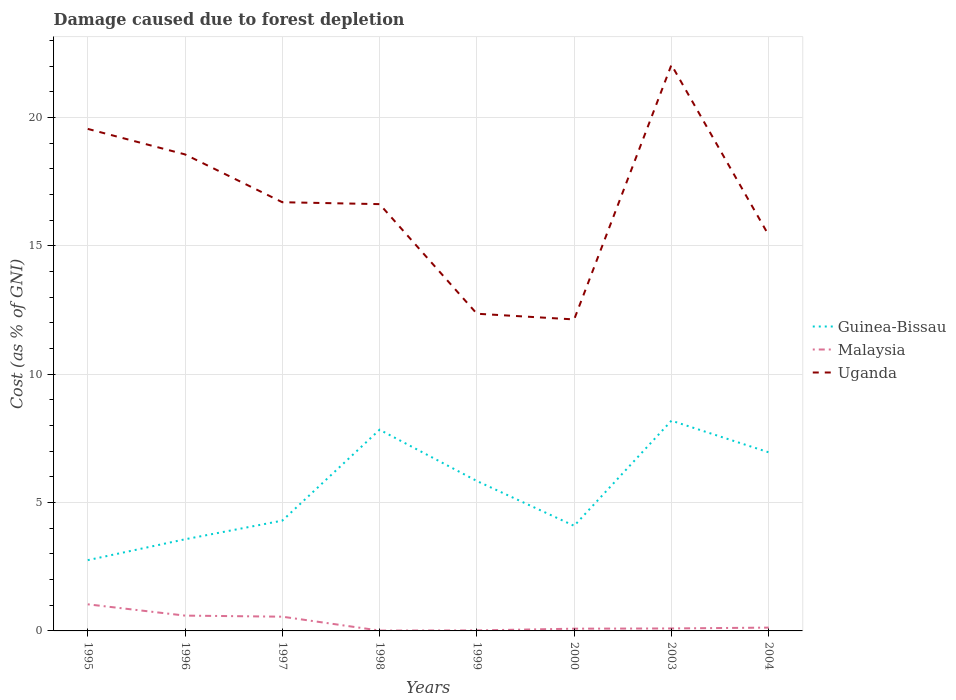Does the line corresponding to Malaysia intersect with the line corresponding to Uganda?
Offer a very short reply. No. Across all years, what is the maximum cost of damage caused due to forest depletion in Guinea-Bissau?
Provide a succinct answer. 2.76. In which year was the cost of damage caused due to forest depletion in Malaysia maximum?
Give a very brief answer. 1998. What is the total cost of damage caused due to forest depletion in Uganda in the graph?
Offer a terse response. 6.21. What is the difference between the highest and the second highest cost of damage caused due to forest depletion in Uganda?
Make the answer very short. 9.91. What is the difference between the highest and the lowest cost of damage caused due to forest depletion in Guinea-Bissau?
Your answer should be compact. 4. How many lines are there?
Your answer should be very brief. 3. Are the values on the major ticks of Y-axis written in scientific E-notation?
Your answer should be compact. No. Does the graph contain any zero values?
Ensure brevity in your answer.  No. What is the title of the graph?
Make the answer very short. Damage caused due to forest depletion. What is the label or title of the X-axis?
Offer a very short reply. Years. What is the label or title of the Y-axis?
Ensure brevity in your answer.  Cost (as % of GNI). What is the Cost (as % of GNI) in Guinea-Bissau in 1995?
Provide a succinct answer. 2.76. What is the Cost (as % of GNI) of Malaysia in 1995?
Provide a short and direct response. 1.04. What is the Cost (as % of GNI) of Uganda in 1995?
Give a very brief answer. 19.55. What is the Cost (as % of GNI) of Guinea-Bissau in 1996?
Offer a very short reply. 3.57. What is the Cost (as % of GNI) of Malaysia in 1996?
Your answer should be compact. 0.6. What is the Cost (as % of GNI) in Uganda in 1996?
Your answer should be very brief. 18.56. What is the Cost (as % of GNI) in Guinea-Bissau in 1997?
Provide a succinct answer. 4.3. What is the Cost (as % of GNI) of Malaysia in 1997?
Your response must be concise. 0.55. What is the Cost (as % of GNI) of Uganda in 1997?
Keep it short and to the point. 16.7. What is the Cost (as % of GNI) of Guinea-Bissau in 1998?
Keep it short and to the point. 7.84. What is the Cost (as % of GNI) in Malaysia in 1998?
Your response must be concise. 0.01. What is the Cost (as % of GNI) in Uganda in 1998?
Your response must be concise. 16.62. What is the Cost (as % of GNI) of Guinea-Bissau in 1999?
Provide a succinct answer. 5.84. What is the Cost (as % of GNI) in Malaysia in 1999?
Provide a succinct answer. 0.02. What is the Cost (as % of GNI) of Uganda in 1999?
Your answer should be compact. 12.35. What is the Cost (as % of GNI) of Guinea-Bissau in 2000?
Give a very brief answer. 4.09. What is the Cost (as % of GNI) of Malaysia in 2000?
Ensure brevity in your answer.  0.09. What is the Cost (as % of GNI) in Uganda in 2000?
Keep it short and to the point. 12.13. What is the Cost (as % of GNI) of Guinea-Bissau in 2003?
Provide a succinct answer. 8.19. What is the Cost (as % of GNI) of Malaysia in 2003?
Your answer should be very brief. 0.1. What is the Cost (as % of GNI) of Uganda in 2003?
Your answer should be compact. 22.05. What is the Cost (as % of GNI) of Guinea-Bissau in 2004?
Give a very brief answer. 6.96. What is the Cost (as % of GNI) of Malaysia in 2004?
Your answer should be very brief. 0.13. What is the Cost (as % of GNI) of Uganda in 2004?
Provide a succinct answer. 15.41. Across all years, what is the maximum Cost (as % of GNI) in Guinea-Bissau?
Offer a terse response. 8.19. Across all years, what is the maximum Cost (as % of GNI) of Malaysia?
Offer a terse response. 1.04. Across all years, what is the maximum Cost (as % of GNI) of Uganda?
Make the answer very short. 22.05. Across all years, what is the minimum Cost (as % of GNI) in Guinea-Bissau?
Make the answer very short. 2.76. Across all years, what is the minimum Cost (as % of GNI) in Malaysia?
Give a very brief answer. 0.01. Across all years, what is the minimum Cost (as % of GNI) in Uganda?
Offer a terse response. 12.13. What is the total Cost (as % of GNI) in Guinea-Bissau in the graph?
Keep it short and to the point. 43.53. What is the total Cost (as % of GNI) of Malaysia in the graph?
Offer a very short reply. 2.53. What is the total Cost (as % of GNI) in Uganda in the graph?
Provide a short and direct response. 133.36. What is the difference between the Cost (as % of GNI) of Guinea-Bissau in 1995 and that in 1996?
Offer a very short reply. -0.81. What is the difference between the Cost (as % of GNI) of Malaysia in 1995 and that in 1996?
Ensure brevity in your answer.  0.44. What is the difference between the Cost (as % of GNI) of Guinea-Bissau in 1995 and that in 1997?
Your response must be concise. -1.54. What is the difference between the Cost (as % of GNI) of Malaysia in 1995 and that in 1997?
Give a very brief answer. 0.48. What is the difference between the Cost (as % of GNI) in Uganda in 1995 and that in 1997?
Your response must be concise. 2.86. What is the difference between the Cost (as % of GNI) in Guinea-Bissau in 1995 and that in 1998?
Provide a short and direct response. -5.08. What is the difference between the Cost (as % of GNI) in Malaysia in 1995 and that in 1998?
Provide a succinct answer. 1.02. What is the difference between the Cost (as % of GNI) of Uganda in 1995 and that in 1998?
Give a very brief answer. 2.93. What is the difference between the Cost (as % of GNI) of Guinea-Bissau in 1995 and that in 1999?
Keep it short and to the point. -3.08. What is the difference between the Cost (as % of GNI) in Malaysia in 1995 and that in 1999?
Provide a short and direct response. 1.02. What is the difference between the Cost (as % of GNI) in Uganda in 1995 and that in 1999?
Make the answer very short. 7.2. What is the difference between the Cost (as % of GNI) of Guinea-Bissau in 1995 and that in 2000?
Make the answer very short. -1.34. What is the difference between the Cost (as % of GNI) of Malaysia in 1995 and that in 2000?
Provide a succinct answer. 0.95. What is the difference between the Cost (as % of GNI) of Uganda in 1995 and that in 2000?
Ensure brevity in your answer.  7.42. What is the difference between the Cost (as % of GNI) in Guinea-Bissau in 1995 and that in 2003?
Your answer should be compact. -5.43. What is the difference between the Cost (as % of GNI) in Malaysia in 1995 and that in 2003?
Offer a very short reply. 0.94. What is the difference between the Cost (as % of GNI) of Uganda in 1995 and that in 2003?
Offer a terse response. -2.49. What is the difference between the Cost (as % of GNI) of Guinea-Bissau in 1995 and that in 2004?
Offer a terse response. -4.2. What is the difference between the Cost (as % of GNI) in Malaysia in 1995 and that in 2004?
Provide a succinct answer. 0.91. What is the difference between the Cost (as % of GNI) of Uganda in 1995 and that in 2004?
Provide a succinct answer. 4.14. What is the difference between the Cost (as % of GNI) in Guinea-Bissau in 1996 and that in 1997?
Your response must be concise. -0.73. What is the difference between the Cost (as % of GNI) of Malaysia in 1996 and that in 1997?
Provide a succinct answer. 0.04. What is the difference between the Cost (as % of GNI) in Uganda in 1996 and that in 1997?
Provide a succinct answer. 1.86. What is the difference between the Cost (as % of GNI) in Guinea-Bissau in 1996 and that in 1998?
Ensure brevity in your answer.  -4.27. What is the difference between the Cost (as % of GNI) in Malaysia in 1996 and that in 1998?
Make the answer very short. 0.58. What is the difference between the Cost (as % of GNI) of Uganda in 1996 and that in 1998?
Give a very brief answer. 1.94. What is the difference between the Cost (as % of GNI) of Guinea-Bissau in 1996 and that in 1999?
Keep it short and to the point. -2.27. What is the difference between the Cost (as % of GNI) of Malaysia in 1996 and that in 1999?
Give a very brief answer. 0.58. What is the difference between the Cost (as % of GNI) in Uganda in 1996 and that in 1999?
Keep it short and to the point. 6.21. What is the difference between the Cost (as % of GNI) of Guinea-Bissau in 1996 and that in 2000?
Your response must be concise. -0.52. What is the difference between the Cost (as % of GNI) of Malaysia in 1996 and that in 2000?
Your answer should be very brief. 0.51. What is the difference between the Cost (as % of GNI) of Uganda in 1996 and that in 2000?
Make the answer very short. 6.43. What is the difference between the Cost (as % of GNI) of Guinea-Bissau in 1996 and that in 2003?
Provide a succinct answer. -4.62. What is the difference between the Cost (as % of GNI) of Malaysia in 1996 and that in 2003?
Your response must be concise. 0.5. What is the difference between the Cost (as % of GNI) of Uganda in 1996 and that in 2003?
Provide a succinct answer. -3.49. What is the difference between the Cost (as % of GNI) of Guinea-Bissau in 1996 and that in 2004?
Keep it short and to the point. -3.39. What is the difference between the Cost (as % of GNI) in Malaysia in 1996 and that in 2004?
Provide a succinct answer. 0.47. What is the difference between the Cost (as % of GNI) in Uganda in 1996 and that in 2004?
Give a very brief answer. 3.15. What is the difference between the Cost (as % of GNI) of Guinea-Bissau in 1997 and that in 1998?
Provide a succinct answer. -3.54. What is the difference between the Cost (as % of GNI) in Malaysia in 1997 and that in 1998?
Ensure brevity in your answer.  0.54. What is the difference between the Cost (as % of GNI) of Uganda in 1997 and that in 1998?
Your response must be concise. 0.07. What is the difference between the Cost (as % of GNI) in Guinea-Bissau in 1997 and that in 1999?
Keep it short and to the point. -1.54. What is the difference between the Cost (as % of GNI) in Malaysia in 1997 and that in 1999?
Offer a very short reply. 0.53. What is the difference between the Cost (as % of GNI) in Uganda in 1997 and that in 1999?
Your answer should be compact. 4.34. What is the difference between the Cost (as % of GNI) of Guinea-Bissau in 1997 and that in 2000?
Offer a terse response. 0.2. What is the difference between the Cost (as % of GNI) in Malaysia in 1997 and that in 2000?
Your answer should be very brief. 0.47. What is the difference between the Cost (as % of GNI) of Uganda in 1997 and that in 2000?
Offer a terse response. 4.56. What is the difference between the Cost (as % of GNI) of Guinea-Bissau in 1997 and that in 2003?
Ensure brevity in your answer.  -3.89. What is the difference between the Cost (as % of GNI) of Malaysia in 1997 and that in 2003?
Your response must be concise. 0.46. What is the difference between the Cost (as % of GNI) of Uganda in 1997 and that in 2003?
Offer a terse response. -5.35. What is the difference between the Cost (as % of GNI) of Guinea-Bissau in 1997 and that in 2004?
Offer a very short reply. -2.66. What is the difference between the Cost (as % of GNI) of Malaysia in 1997 and that in 2004?
Make the answer very short. 0.43. What is the difference between the Cost (as % of GNI) in Uganda in 1997 and that in 2004?
Offer a terse response. 1.29. What is the difference between the Cost (as % of GNI) in Guinea-Bissau in 1998 and that in 1999?
Your response must be concise. 2. What is the difference between the Cost (as % of GNI) in Malaysia in 1998 and that in 1999?
Your answer should be compact. -0.01. What is the difference between the Cost (as % of GNI) in Uganda in 1998 and that in 1999?
Provide a succinct answer. 4.27. What is the difference between the Cost (as % of GNI) of Guinea-Bissau in 1998 and that in 2000?
Offer a terse response. 3.74. What is the difference between the Cost (as % of GNI) in Malaysia in 1998 and that in 2000?
Provide a succinct answer. -0.07. What is the difference between the Cost (as % of GNI) in Uganda in 1998 and that in 2000?
Keep it short and to the point. 4.49. What is the difference between the Cost (as % of GNI) of Guinea-Bissau in 1998 and that in 2003?
Make the answer very short. -0.35. What is the difference between the Cost (as % of GNI) in Malaysia in 1998 and that in 2003?
Provide a short and direct response. -0.08. What is the difference between the Cost (as % of GNI) in Uganda in 1998 and that in 2003?
Give a very brief answer. -5.42. What is the difference between the Cost (as % of GNI) of Guinea-Bissau in 1998 and that in 2004?
Your answer should be compact. 0.88. What is the difference between the Cost (as % of GNI) of Malaysia in 1998 and that in 2004?
Provide a short and direct response. -0.11. What is the difference between the Cost (as % of GNI) of Uganda in 1998 and that in 2004?
Your answer should be very brief. 1.21. What is the difference between the Cost (as % of GNI) in Guinea-Bissau in 1999 and that in 2000?
Your response must be concise. 1.75. What is the difference between the Cost (as % of GNI) in Malaysia in 1999 and that in 2000?
Make the answer very short. -0.07. What is the difference between the Cost (as % of GNI) in Uganda in 1999 and that in 2000?
Your answer should be very brief. 0.22. What is the difference between the Cost (as % of GNI) in Guinea-Bissau in 1999 and that in 2003?
Your answer should be very brief. -2.35. What is the difference between the Cost (as % of GNI) in Malaysia in 1999 and that in 2003?
Make the answer very short. -0.08. What is the difference between the Cost (as % of GNI) in Uganda in 1999 and that in 2003?
Your answer should be compact. -9.69. What is the difference between the Cost (as % of GNI) of Guinea-Bissau in 1999 and that in 2004?
Your answer should be very brief. -1.12. What is the difference between the Cost (as % of GNI) in Malaysia in 1999 and that in 2004?
Provide a succinct answer. -0.11. What is the difference between the Cost (as % of GNI) of Uganda in 1999 and that in 2004?
Provide a succinct answer. -3.06. What is the difference between the Cost (as % of GNI) of Guinea-Bissau in 2000 and that in 2003?
Make the answer very short. -4.1. What is the difference between the Cost (as % of GNI) of Malaysia in 2000 and that in 2003?
Your answer should be compact. -0.01. What is the difference between the Cost (as % of GNI) of Uganda in 2000 and that in 2003?
Your response must be concise. -9.91. What is the difference between the Cost (as % of GNI) of Guinea-Bissau in 2000 and that in 2004?
Provide a succinct answer. -2.86. What is the difference between the Cost (as % of GNI) in Malaysia in 2000 and that in 2004?
Your answer should be compact. -0.04. What is the difference between the Cost (as % of GNI) of Uganda in 2000 and that in 2004?
Give a very brief answer. -3.28. What is the difference between the Cost (as % of GNI) in Guinea-Bissau in 2003 and that in 2004?
Make the answer very short. 1.23. What is the difference between the Cost (as % of GNI) of Malaysia in 2003 and that in 2004?
Provide a short and direct response. -0.03. What is the difference between the Cost (as % of GNI) of Uganda in 2003 and that in 2004?
Your answer should be compact. 6.64. What is the difference between the Cost (as % of GNI) of Guinea-Bissau in 1995 and the Cost (as % of GNI) of Malaysia in 1996?
Your answer should be very brief. 2.16. What is the difference between the Cost (as % of GNI) of Guinea-Bissau in 1995 and the Cost (as % of GNI) of Uganda in 1996?
Offer a very short reply. -15.8. What is the difference between the Cost (as % of GNI) in Malaysia in 1995 and the Cost (as % of GNI) in Uganda in 1996?
Provide a short and direct response. -17.52. What is the difference between the Cost (as % of GNI) in Guinea-Bissau in 1995 and the Cost (as % of GNI) in Malaysia in 1997?
Keep it short and to the point. 2.2. What is the difference between the Cost (as % of GNI) of Guinea-Bissau in 1995 and the Cost (as % of GNI) of Uganda in 1997?
Ensure brevity in your answer.  -13.94. What is the difference between the Cost (as % of GNI) of Malaysia in 1995 and the Cost (as % of GNI) of Uganda in 1997?
Provide a succinct answer. -15.66. What is the difference between the Cost (as % of GNI) of Guinea-Bissau in 1995 and the Cost (as % of GNI) of Malaysia in 1998?
Keep it short and to the point. 2.74. What is the difference between the Cost (as % of GNI) in Guinea-Bissau in 1995 and the Cost (as % of GNI) in Uganda in 1998?
Provide a succinct answer. -13.87. What is the difference between the Cost (as % of GNI) in Malaysia in 1995 and the Cost (as % of GNI) in Uganda in 1998?
Make the answer very short. -15.59. What is the difference between the Cost (as % of GNI) in Guinea-Bissau in 1995 and the Cost (as % of GNI) in Malaysia in 1999?
Provide a succinct answer. 2.74. What is the difference between the Cost (as % of GNI) in Guinea-Bissau in 1995 and the Cost (as % of GNI) in Uganda in 1999?
Your response must be concise. -9.6. What is the difference between the Cost (as % of GNI) of Malaysia in 1995 and the Cost (as % of GNI) of Uganda in 1999?
Offer a terse response. -11.32. What is the difference between the Cost (as % of GNI) in Guinea-Bissau in 1995 and the Cost (as % of GNI) in Malaysia in 2000?
Provide a short and direct response. 2.67. What is the difference between the Cost (as % of GNI) in Guinea-Bissau in 1995 and the Cost (as % of GNI) in Uganda in 2000?
Offer a terse response. -9.38. What is the difference between the Cost (as % of GNI) in Malaysia in 1995 and the Cost (as % of GNI) in Uganda in 2000?
Your answer should be compact. -11.1. What is the difference between the Cost (as % of GNI) in Guinea-Bissau in 1995 and the Cost (as % of GNI) in Malaysia in 2003?
Give a very brief answer. 2.66. What is the difference between the Cost (as % of GNI) of Guinea-Bissau in 1995 and the Cost (as % of GNI) of Uganda in 2003?
Your answer should be very brief. -19.29. What is the difference between the Cost (as % of GNI) of Malaysia in 1995 and the Cost (as % of GNI) of Uganda in 2003?
Offer a very short reply. -21.01. What is the difference between the Cost (as % of GNI) of Guinea-Bissau in 1995 and the Cost (as % of GNI) of Malaysia in 2004?
Your answer should be very brief. 2.63. What is the difference between the Cost (as % of GNI) in Guinea-Bissau in 1995 and the Cost (as % of GNI) in Uganda in 2004?
Give a very brief answer. -12.65. What is the difference between the Cost (as % of GNI) of Malaysia in 1995 and the Cost (as % of GNI) of Uganda in 2004?
Your answer should be compact. -14.37. What is the difference between the Cost (as % of GNI) in Guinea-Bissau in 1996 and the Cost (as % of GNI) in Malaysia in 1997?
Ensure brevity in your answer.  3.01. What is the difference between the Cost (as % of GNI) in Guinea-Bissau in 1996 and the Cost (as % of GNI) in Uganda in 1997?
Give a very brief answer. -13.13. What is the difference between the Cost (as % of GNI) of Malaysia in 1996 and the Cost (as % of GNI) of Uganda in 1997?
Your answer should be very brief. -16.1. What is the difference between the Cost (as % of GNI) of Guinea-Bissau in 1996 and the Cost (as % of GNI) of Malaysia in 1998?
Make the answer very short. 3.55. What is the difference between the Cost (as % of GNI) in Guinea-Bissau in 1996 and the Cost (as % of GNI) in Uganda in 1998?
Keep it short and to the point. -13.05. What is the difference between the Cost (as % of GNI) of Malaysia in 1996 and the Cost (as % of GNI) of Uganda in 1998?
Offer a terse response. -16.02. What is the difference between the Cost (as % of GNI) of Guinea-Bissau in 1996 and the Cost (as % of GNI) of Malaysia in 1999?
Your answer should be compact. 3.55. What is the difference between the Cost (as % of GNI) in Guinea-Bissau in 1996 and the Cost (as % of GNI) in Uganda in 1999?
Offer a very short reply. -8.78. What is the difference between the Cost (as % of GNI) of Malaysia in 1996 and the Cost (as % of GNI) of Uganda in 1999?
Provide a succinct answer. -11.76. What is the difference between the Cost (as % of GNI) of Guinea-Bissau in 1996 and the Cost (as % of GNI) of Malaysia in 2000?
Offer a terse response. 3.48. What is the difference between the Cost (as % of GNI) of Guinea-Bissau in 1996 and the Cost (as % of GNI) of Uganda in 2000?
Offer a terse response. -8.56. What is the difference between the Cost (as % of GNI) in Malaysia in 1996 and the Cost (as % of GNI) in Uganda in 2000?
Offer a very short reply. -11.53. What is the difference between the Cost (as % of GNI) in Guinea-Bissau in 1996 and the Cost (as % of GNI) in Malaysia in 2003?
Offer a terse response. 3.47. What is the difference between the Cost (as % of GNI) in Guinea-Bissau in 1996 and the Cost (as % of GNI) in Uganda in 2003?
Your answer should be very brief. -18.48. What is the difference between the Cost (as % of GNI) of Malaysia in 1996 and the Cost (as % of GNI) of Uganda in 2003?
Give a very brief answer. -21.45. What is the difference between the Cost (as % of GNI) of Guinea-Bissau in 1996 and the Cost (as % of GNI) of Malaysia in 2004?
Keep it short and to the point. 3.44. What is the difference between the Cost (as % of GNI) in Guinea-Bissau in 1996 and the Cost (as % of GNI) in Uganda in 2004?
Offer a terse response. -11.84. What is the difference between the Cost (as % of GNI) in Malaysia in 1996 and the Cost (as % of GNI) in Uganda in 2004?
Provide a short and direct response. -14.81. What is the difference between the Cost (as % of GNI) in Guinea-Bissau in 1997 and the Cost (as % of GNI) in Malaysia in 1998?
Keep it short and to the point. 4.28. What is the difference between the Cost (as % of GNI) in Guinea-Bissau in 1997 and the Cost (as % of GNI) in Uganda in 1998?
Keep it short and to the point. -12.33. What is the difference between the Cost (as % of GNI) of Malaysia in 1997 and the Cost (as % of GNI) of Uganda in 1998?
Your answer should be compact. -16.07. What is the difference between the Cost (as % of GNI) in Guinea-Bissau in 1997 and the Cost (as % of GNI) in Malaysia in 1999?
Give a very brief answer. 4.28. What is the difference between the Cost (as % of GNI) of Guinea-Bissau in 1997 and the Cost (as % of GNI) of Uganda in 1999?
Keep it short and to the point. -8.06. What is the difference between the Cost (as % of GNI) in Malaysia in 1997 and the Cost (as % of GNI) in Uganda in 1999?
Ensure brevity in your answer.  -11.8. What is the difference between the Cost (as % of GNI) in Guinea-Bissau in 1997 and the Cost (as % of GNI) in Malaysia in 2000?
Your response must be concise. 4.21. What is the difference between the Cost (as % of GNI) in Guinea-Bissau in 1997 and the Cost (as % of GNI) in Uganda in 2000?
Provide a short and direct response. -7.84. What is the difference between the Cost (as % of GNI) in Malaysia in 1997 and the Cost (as % of GNI) in Uganda in 2000?
Offer a very short reply. -11.58. What is the difference between the Cost (as % of GNI) of Guinea-Bissau in 1997 and the Cost (as % of GNI) of Malaysia in 2003?
Offer a terse response. 4.2. What is the difference between the Cost (as % of GNI) in Guinea-Bissau in 1997 and the Cost (as % of GNI) in Uganda in 2003?
Make the answer very short. -17.75. What is the difference between the Cost (as % of GNI) of Malaysia in 1997 and the Cost (as % of GNI) of Uganda in 2003?
Make the answer very short. -21.49. What is the difference between the Cost (as % of GNI) in Guinea-Bissau in 1997 and the Cost (as % of GNI) in Malaysia in 2004?
Offer a very short reply. 4.17. What is the difference between the Cost (as % of GNI) in Guinea-Bissau in 1997 and the Cost (as % of GNI) in Uganda in 2004?
Keep it short and to the point. -11.11. What is the difference between the Cost (as % of GNI) of Malaysia in 1997 and the Cost (as % of GNI) of Uganda in 2004?
Keep it short and to the point. -14.85. What is the difference between the Cost (as % of GNI) of Guinea-Bissau in 1998 and the Cost (as % of GNI) of Malaysia in 1999?
Provide a succinct answer. 7.82. What is the difference between the Cost (as % of GNI) in Guinea-Bissau in 1998 and the Cost (as % of GNI) in Uganda in 1999?
Make the answer very short. -4.52. What is the difference between the Cost (as % of GNI) of Malaysia in 1998 and the Cost (as % of GNI) of Uganda in 1999?
Your answer should be compact. -12.34. What is the difference between the Cost (as % of GNI) of Guinea-Bissau in 1998 and the Cost (as % of GNI) of Malaysia in 2000?
Your answer should be compact. 7.75. What is the difference between the Cost (as % of GNI) of Guinea-Bissau in 1998 and the Cost (as % of GNI) of Uganda in 2000?
Offer a terse response. -4.3. What is the difference between the Cost (as % of GNI) in Malaysia in 1998 and the Cost (as % of GNI) in Uganda in 2000?
Provide a short and direct response. -12.12. What is the difference between the Cost (as % of GNI) in Guinea-Bissau in 1998 and the Cost (as % of GNI) in Malaysia in 2003?
Make the answer very short. 7.74. What is the difference between the Cost (as % of GNI) of Guinea-Bissau in 1998 and the Cost (as % of GNI) of Uganda in 2003?
Your response must be concise. -14.21. What is the difference between the Cost (as % of GNI) in Malaysia in 1998 and the Cost (as % of GNI) in Uganda in 2003?
Provide a short and direct response. -22.03. What is the difference between the Cost (as % of GNI) of Guinea-Bissau in 1998 and the Cost (as % of GNI) of Malaysia in 2004?
Offer a very short reply. 7.71. What is the difference between the Cost (as % of GNI) of Guinea-Bissau in 1998 and the Cost (as % of GNI) of Uganda in 2004?
Your answer should be very brief. -7.57. What is the difference between the Cost (as % of GNI) of Malaysia in 1998 and the Cost (as % of GNI) of Uganda in 2004?
Keep it short and to the point. -15.39. What is the difference between the Cost (as % of GNI) in Guinea-Bissau in 1999 and the Cost (as % of GNI) in Malaysia in 2000?
Offer a terse response. 5.75. What is the difference between the Cost (as % of GNI) of Guinea-Bissau in 1999 and the Cost (as % of GNI) of Uganda in 2000?
Ensure brevity in your answer.  -6.29. What is the difference between the Cost (as % of GNI) of Malaysia in 1999 and the Cost (as % of GNI) of Uganda in 2000?
Give a very brief answer. -12.11. What is the difference between the Cost (as % of GNI) in Guinea-Bissau in 1999 and the Cost (as % of GNI) in Malaysia in 2003?
Provide a short and direct response. 5.74. What is the difference between the Cost (as % of GNI) in Guinea-Bissau in 1999 and the Cost (as % of GNI) in Uganda in 2003?
Ensure brevity in your answer.  -16.21. What is the difference between the Cost (as % of GNI) of Malaysia in 1999 and the Cost (as % of GNI) of Uganda in 2003?
Provide a short and direct response. -22.03. What is the difference between the Cost (as % of GNI) of Guinea-Bissau in 1999 and the Cost (as % of GNI) of Malaysia in 2004?
Offer a terse response. 5.71. What is the difference between the Cost (as % of GNI) in Guinea-Bissau in 1999 and the Cost (as % of GNI) in Uganda in 2004?
Give a very brief answer. -9.57. What is the difference between the Cost (as % of GNI) of Malaysia in 1999 and the Cost (as % of GNI) of Uganda in 2004?
Your answer should be very brief. -15.39. What is the difference between the Cost (as % of GNI) in Guinea-Bissau in 2000 and the Cost (as % of GNI) in Malaysia in 2003?
Provide a short and direct response. 4. What is the difference between the Cost (as % of GNI) of Guinea-Bissau in 2000 and the Cost (as % of GNI) of Uganda in 2003?
Provide a short and direct response. -17.95. What is the difference between the Cost (as % of GNI) of Malaysia in 2000 and the Cost (as % of GNI) of Uganda in 2003?
Offer a terse response. -21.96. What is the difference between the Cost (as % of GNI) in Guinea-Bissau in 2000 and the Cost (as % of GNI) in Malaysia in 2004?
Make the answer very short. 3.96. What is the difference between the Cost (as % of GNI) of Guinea-Bissau in 2000 and the Cost (as % of GNI) of Uganda in 2004?
Offer a terse response. -11.32. What is the difference between the Cost (as % of GNI) of Malaysia in 2000 and the Cost (as % of GNI) of Uganda in 2004?
Offer a terse response. -15.32. What is the difference between the Cost (as % of GNI) of Guinea-Bissau in 2003 and the Cost (as % of GNI) of Malaysia in 2004?
Ensure brevity in your answer.  8.06. What is the difference between the Cost (as % of GNI) of Guinea-Bissau in 2003 and the Cost (as % of GNI) of Uganda in 2004?
Make the answer very short. -7.22. What is the difference between the Cost (as % of GNI) of Malaysia in 2003 and the Cost (as % of GNI) of Uganda in 2004?
Offer a terse response. -15.31. What is the average Cost (as % of GNI) of Guinea-Bissau per year?
Your answer should be compact. 5.44. What is the average Cost (as % of GNI) of Malaysia per year?
Give a very brief answer. 0.32. What is the average Cost (as % of GNI) of Uganda per year?
Keep it short and to the point. 16.67. In the year 1995, what is the difference between the Cost (as % of GNI) in Guinea-Bissau and Cost (as % of GNI) in Malaysia?
Your answer should be compact. 1.72. In the year 1995, what is the difference between the Cost (as % of GNI) of Guinea-Bissau and Cost (as % of GNI) of Uganda?
Provide a succinct answer. -16.8. In the year 1995, what is the difference between the Cost (as % of GNI) in Malaysia and Cost (as % of GNI) in Uganda?
Offer a terse response. -18.52. In the year 1996, what is the difference between the Cost (as % of GNI) in Guinea-Bissau and Cost (as % of GNI) in Malaysia?
Make the answer very short. 2.97. In the year 1996, what is the difference between the Cost (as % of GNI) in Guinea-Bissau and Cost (as % of GNI) in Uganda?
Give a very brief answer. -14.99. In the year 1996, what is the difference between the Cost (as % of GNI) in Malaysia and Cost (as % of GNI) in Uganda?
Keep it short and to the point. -17.96. In the year 1997, what is the difference between the Cost (as % of GNI) in Guinea-Bissau and Cost (as % of GNI) in Malaysia?
Offer a terse response. 3.74. In the year 1997, what is the difference between the Cost (as % of GNI) of Guinea-Bissau and Cost (as % of GNI) of Uganda?
Keep it short and to the point. -12.4. In the year 1997, what is the difference between the Cost (as % of GNI) of Malaysia and Cost (as % of GNI) of Uganda?
Offer a very short reply. -16.14. In the year 1998, what is the difference between the Cost (as % of GNI) of Guinea-Bissau and Cost (as % of GNI) of Malaysia?
Your answer should be compact. 7.82. In the year 1998, what is the difference between the Cost (as % of GNI) of Guinea-Bissau and Cost (as % of GNI) of Uganda?
Give a very brief answer. -8.79. In the year 1998, what is the difference between the Cost (as % of GNI) in Malaysia and Cost (as % of GNI) in Uganda?
Offer a terse response. -16.61. In the year 1999, what is the difference between the Cost (as % of GNI) in Guinea-Bissau and Cost (as % of GNI) in Malaysia?
Your answer should be compact. 5.82. In the year 1999, what is the difference between the Cost (as % of GNI) in Guinea-Bissau and Cost (as % of GNI) in Uganda?
Your response must be concise. -6.51. In the year 1999, what is the difference between the Cost (as % of GNI) in Malaysia and Cost (as % of GNI) in Uganda?
Offer a very short reply. -12.33. In the year 2000, what is the difference between the Cost (as % of GNI) in Guinea-Bissau and Cost (as % of GNI) in Malaysia?
Ensure brevity in your answer.  4.01. In the year 2000, what is the difference between the Cost (as % of GNI) of Guinea-Bissau and Cost (as % of GNI) of Uganda?
Give a very brief answer. -8.04. In the year 2000, what is the difference between the Cost (as % of GNI) in Malaysia and Cost (as % of GNI) in Uganda?
Provide a short and direct response. -12.04. In the year 2003, what is the difference between the Cost (as % of GNI) of Guinea-Bissau and Cost (as % of GNI) of Malaysia?
Keep it short and to the point. 8.09. In the year 2003, what is the difference between the Cost (as % of GNI) in Guinea-Bissau and Cost (as % of GNI) in Uganda?
Provide a succinct answer. -13.86. In the year 2003, what is the difference between the Cost (as % of GNI) of Malaysia and Cost (as % of GNI) of Uganda?
Your answer should be compact. -21.95. In the year 2004, what is the difference between the Cost (as % of GNI) of Guinea-Bissau and Cost (as % of GNI) of Malaysia?
Offer a terse response. 6.83. In the year 2004, what is the difference between the Cost (as % of GNI) of Guinea-Bissau and Cost (as % of GNI) of Uganda?
Your answer should be very brief. -8.45. In the year 2004, what is the difference between the Cost (as % of GNI) in Malaysia and Cost (as % of GNI) in Uganda?
Make the answer very short. -15.28. What is the ratio of the Cost (as % of GNI) in Guinea-Bissau in 1995 to that in 1996?
Offer a terse response. 0.77. What is the ratio of the Cost (as % of GNI) in Malaysia in 1995 to that in 1996?
Ensure brevity in your answer.  1.74. What is the ratio of the Cost (as % of GNI) of Uganda in 1995 to that in 1996?
Ensure brevity in your answer.  1.05. What is the ratio of the Cost (as % of GNI) in Guinea-Bissau in 1995 to that in 1997?
Offer a very short reply. 0.64. What is the ratio of the Cost (as % of GNI) of Malaysia in 1995 to that in 1997?
Give a very brief answer. 1.87. What is the ratio of the Cost (as % of GNI) in Uganda in 1995 to that in 1997?
Ensure brevity in your answer.  1.17. What is the ratio of the Cost (as % of GNI) in Guinea-Bissau in 1995 to that in 1998?
Your answer should be compact. 0.35. What is the ratio of the Cost (as % of GNI) in Malaysia in 1995 to that in 1998?
Offer a very short reply. 73.46. What is the ratio of the Cost (as % of GNI) in Uganda in 1995 to that in 1998?
Keep it short and to the point. 1.18. What is the ratio of the Cost (as % of GNI) in Guinea-Bissau in 1995 to that in 1999?
Provide a short and direct response. 0.47. What is the ratio of the Cost (as % of GNI) in Malaysia in 1995 to that in 1999?
Offer a very short reply. 52.17. What is the ratio of the Cost (as % of GNI) in Uganda in 1995 to that in 1999?
Your answer should be very brief. 1.58. What is the ratio of the Cost (as % of GNI) in Guinea-Bissau in 1995 to that in 2000?
Provide a short and direct response. 0.67. What is the ratio of the Cost (as % of GNI) in Malaysia in 1995 to that in 2000?
Provide a succinct answer. 11.87. What is the ratio of the Cost (as % of GNI) of Uganda in 1995 to that in 2000?
Give a very brief answer. 1.61. What is the ratio of the Cost (as % of GNI) in Guinea-Bissau in 1995 to that in 2003?
Provide a short and direct response. 0.34. What is the ratio of the Cost (as % of GNI) in Malaysia in 1995 to that in 2003?
Keep it short and to the point. 10.79. What is the ratio of the Cost (as % of GNI) of Uganda in 1995 to that in 2003?
Offer a terse response. 0.89. What is the ratio of the Cost (as % of GNI) in Guinea-Bissau in 1995 to that in 2004?
Provide a short and direct response. 0.4. What is the ratio of the Cost (as % of GNI) of Malaysia in 1995 to that in 2004?
Ensure brevity in your answer.  8.04. What is the ratio of the Cost (as % of GNI) of Uganda in 1995 to that in 2004?
Your answer should be compact. 1.27. What is the ratio of the Cost (as % of GNI) in Guinea-Bissau in 1996 to that in 1997?
Keep it short and to the point. 0.83. What is the ratio of the Cost (as % of GNI) in Malaysia in 1996 to that in 1997?
Your answer should be very brief. 1.08. What is the ratio of the Cost (as % of GNI) in Uganda in 1996 to that in 1997?
Provide a short and direct response. 1.11. What is the ratio of the Cost (as % of GNI) in Guinea-Bissau in 1996 to that in 1998?
Ensure brevity in your answer.  0.46. What is the ratio of the Cost (as % of GNI) in Malaysia in 1996 to that in 1998?
Your answer should be compact. 42.29. What is the ratio of the Cost (as % of GNI) in Uganda in 1996 to that in 1998?
Your answer should be compact. 1.12. What is the ratio of the Cost (as % of GNI) of Guinea-Bissau in 1996 to that in 1999?
Provide a succinct answer. 0.61. What is the ratio of the Cost (as % of GNI) of Malaysia in 1996 to that in 1999?
Your answer should be compact. 30.04. What is the ratio of the Cost (as % of GNI) in Uganda in 1996 to that in 1999?
Keep it short and to the point. 1.5. What is the ratio of the Cost (as % of GNI) in Guinea-Bissau in 1996 to that in 2000?
Your answer should be compact. 0.87. What is the ratio of the Cost (as % of GNI) of Malaysia in 1996 to that in 2000?
Provide a succinct answer. 6.83. What is the ratio of the Cost (as % of GNI) in Uganda in 1996 to that in 2000?
Give a very brief answer. 1.53. What is the ratio of the Cost (as % of GNI) in Guinea-Bissau in 1996 to that in 2003?
Give a very brief answer. 0.44. What is the ratio of the Cost (as % of GNI) of Malaysia in 1996 to that in 2003?
Make the answer very short. 6.21. What is the ratio of the Cost (as % of GNI) of Uganda in 1996 to that in 2003?
Your answer should be very brief. 0.84. What is the ratio of the Cost (as % of GNI) of Guinea-Bissau in 1996 to that in 2004?
Your response must be concise. 0.51. What is the ratio of the Cost (as % of GNI) in Malaysia in 1996 to that in 2004?
Your response must be concise. 4.63. What is the ratio of the Cost (as % of GNI) of Uganda in 1996 to that in 2004?
Ensure brevity in your answer.  1.2. What is the ratio of the Cost (as % of GNI) in Guinea-Bissau in 1997 to that in 1998?
Offer a very short reply. 0.55. What is the ratio of the Cost (as % of GNI) in Malaysia in 1997 to that in 1998?
Ensure brevity in your answer.  39.29. What is the ratio of the Cost (as % of GNI) in Guinea-Bissau in 1997 to that in 1999?
Give a very brief answer. 0.74. What is the ratio of the Cost (as % of GNI) in Malaysia in 1997 to that in 1999?
Ensure brevity in your answer.  27.91. What is the ratio of the Cost (as % of GNI) of Uganda in 1997 to that in 1999?
Keep it short and to the point. 1.35. What is the ratio of the Cost (as % of GNI) of Guinea-Bissau in 1997 to that in 2000?
Ensure brevity in your answer.  1.05. What is the ratio of the Cost (as % of GNI) in Malaysia in 1997 to that in 2000?
Offer a very short reply. 6.35. What is the ratio of the Cost (as % of GNI) of Uganda in 1997 to that in 2000?
Provide a succinct answer. 1.38. What is the ratio of the Cost (as % of GNI) in Guinea-Bissau in 1997 to that in 2003?
Offer a very short reply. 0.52. What is the ratio of the Cost (as % of GNI) in Malaysia in 1997 to that in 2003?
Give a very brief answer. 5.77. What is the ratio of the Cost (as % of GNI) in Uganda in 1997 to that in 2003?
Ensure brevity in your answer.  0.76. What is the ratio of the Cost (as % of GNI) of Guinea-Bissau in 1997 to that in 2004?
Make the answer very short. 0.62. What is the ratio of the Cost (as % of GNI) of Malaysia in 1997 to that in 2004?
Keep it short and to the point. 4.3. What is the ratio of the Cost (as % of GNI) of Uganda in 1997 to that in 2004?
Offer a terse response. 1.08. What is the ratio of the Cost (as % of GNI) in Guinea-Bissau in 1998 to that in 1999?
Make the answer very short. 1.34. What is the ratio of the Cost (as % of GNI) in Malaysia in 1998 to that in 1999?
Ensure brevity in your answer.  0.71. What is the ratio of the Cost (as % of GNI) of Uganda in 1998 to that in 1999?
Give a very brief answer. 1.35. What is the ratio of the Cost (as % of GNI) of Guinea-Bissau in 1998 to that in 2000?
Make the answer very short. 1.91. What is the ratio of the Cost (as % of GNI) of Malaysia in 1998 to that in 2000?
Your response must be concise. 0.16. What is the ratio of the Cost (as % of GNI) in Uganda in 1998 to that in 2000?
Provide a short and direct response. 1.37. What is the ratio of the Cost (as % of GNI) in Malaysia in 1998 to that in 2003?
Your response must be concise. 0.15. What is the ratio of the Cost (as % of GNI) of Uganda in 1998 to that in 2003?
Make the answer very short. 0.75. What is the ratio of the Cost (as % of GNI) of Guinea-Bissau in 1998 to that in 2004?
Your answer should be very brief. 1.13. What is the ratio of the Cost (as % of GNI) in Malaysia in 1998 to that in 2004?
Keep it short and to the point. 0.11. What is the ratio of the Cost (as % of GNI) in Uganda in 1998 to that in 2004?
Offer a very short reply. 1.08. What is the ratio of the Cost (as % of GNI) of Guinea-Bissau in 1999 to that in 2000?
Ensure brevity in your answer.  1.43. What is the ratio of the Cost (as % of GNI) in Malaysia in 1999 to that in 2000?
Your answer should be very brief. 0.23. What is the ratio of the Cost (as % of GNI) of Uganda in 1999 to that in 2000?
Give a very brief answer. 1.02. What is the ratio of the Cost (as % of GNI) of Guinea-Bissau in 1999 to that in 2003?
Make the answer very short. 0.71. What is the ratio of the Cost (as % of GNI) in Malaysia in 1999 to that in 2003?
Keep it short and to the point. 0.21. What is the ratio of the Cost (as % of GNI) of Uganda in 1999 to that in 2003?
Your answer should be very brief. 0.56. What is the ratio of the Cost (as % of GNI) in Guinea-Bissau in 1999 to that in 2004?
Your response must be concise. 0.84. What is the ratio of the Cost (as % of GNI) of Malaysia in 1999 to that in 2004?
Ensure brevity in your answer.  0.15. What is the ratio of the Cost (as % of GNI) of Uganda in 1999 to that in 2004?
Keep it short and to the point. 0.8. What is the ratio of the Cost (as % of GNI) of Guinea-Bissau in 2000 to that in 2003?
Make the answer very short. 0.5. What is the ratio of the Cost (as % of GNI) of Malaysia in 2000 to that in 2003?
Your answer should be very brief. 0.91. What is the ratio of the Cost (as % of GNI) in Uganda in 2000 to that in 2003?
Give a very brief answer. 0.55. What is the ratio of the Cost (as % of GNI) of Guinea-Bissau in 2000 to that in 2004?
Make the answer very short. 0.59. What is the ratio of the Cost (as % of GNI) of Malaysia in 2000 to that in 2004?
Give a very brief answer. 0.68. What is the ratio of the Cost (as % of GNI) of Uganda in 2000 to that in 2004?
Your response must be concise. 0.79. What is the ratio of the Cost (as % of GNI) of Guinea-Bissau in 2003 to that in 2004?
Your response must be concise. 1.18. What is the ratio of the Cost (as % of GNI) of Malaysia in 2003 to that in 2004?
Ensure brevity in your answer.  0.74. What is the ratio of the Cost (as % of GNI) in Uganda in 2003 to that in 2004?
Give a very brief answer. 1.43. What is the difference between the highest and the second highest Cost (as % of GNI) in Guinea-Bissau?
Your response must be concise. 0.35. What is the difference between the highest and the second highest Cost (as % of GNI) of Malaysia?
Keep it short and to the point. 0.44. What is the difference between the highest and the second highest Cost (as % of GNI) in Uganda?
Ensure brevity in your answer.  2.49. What is the difference between the highest and the lowest Cost (as % of GNI) in Guinea-Bissau?
Make the answer very short. 5.43. What is the difference between the highest and the lowest Cost (as % of GNI) in Malaysia?
Make the answer very short. 1.02. What is the difference between the highest and the lowest Cost (as % of GNI) of Uganda?
Ensure brevity in your answer.  9.91. 